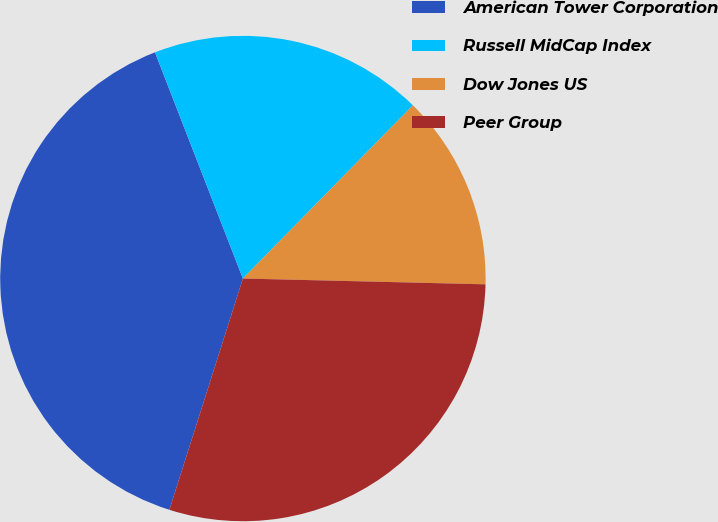Convert chart. <chart><loc_0><loc_0><loc_500><loc_500><pie_chart><fcel>American Tower Corporation<fcel>Russell MidCap Index<fcel>Dow Jones US<fcel>Peer Group<nl><fcel>39.2%<fcel>18.25%<fcel>13.03%<fcel>29.52%<nl></chart> 